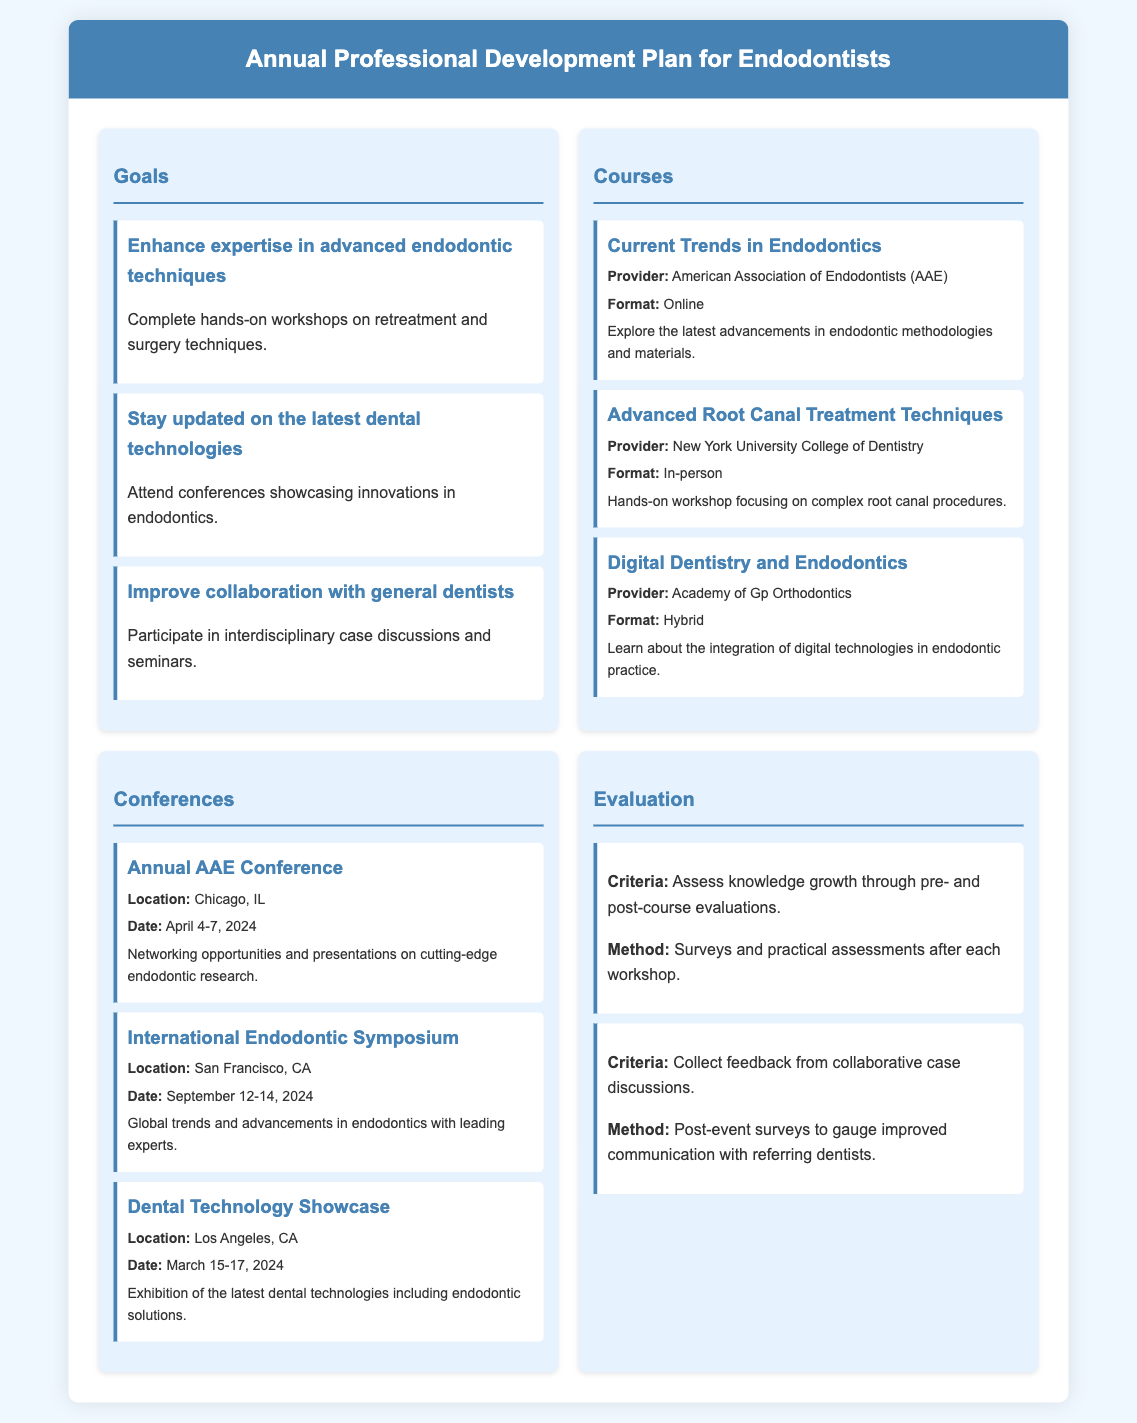What is the title of the document? The title of the document is provided in the header section of the HTML.
Answer: Annual Professional Development Plan for Endodontists How many goals are listed in the document? The number of goals can be counted from the goals section.
Answer: 3 What is the date of the Annual AAE Conference? The date is mentioned in the conference details for the Annual AAE Conference.
Answer: April 4-7, 2024 Which university provides the course on Advanced Root Canal Treatment Techniques? The specific university is outlined in the course details.
Answer: New York University College of Dentistry What is one criterion for evaluating knowledge growth? The criteria are detailed in the evaluation section, specifically assessments mentioned.
Answer: Assess knowledge growth through pre- and post-course evaluations Which city will host the International Endodontic Symposium? This information is provided in the conference section, mentioning the location of the symposium.
Answer: San Francisco, CA How many courses are listed in the document? The number of courses can be counted from the courses section.
Answer: 3 What format is the course on Digital Dentistry and Endodontics offered in? The format is specified in the course details for Digital Dentistry and Endodontics.
Answer: Hybrid What method is used to collect feedback from collaborative case discussions? This method is stated in the evaluation section under feedback collection.
Answer: Post-event surveys 